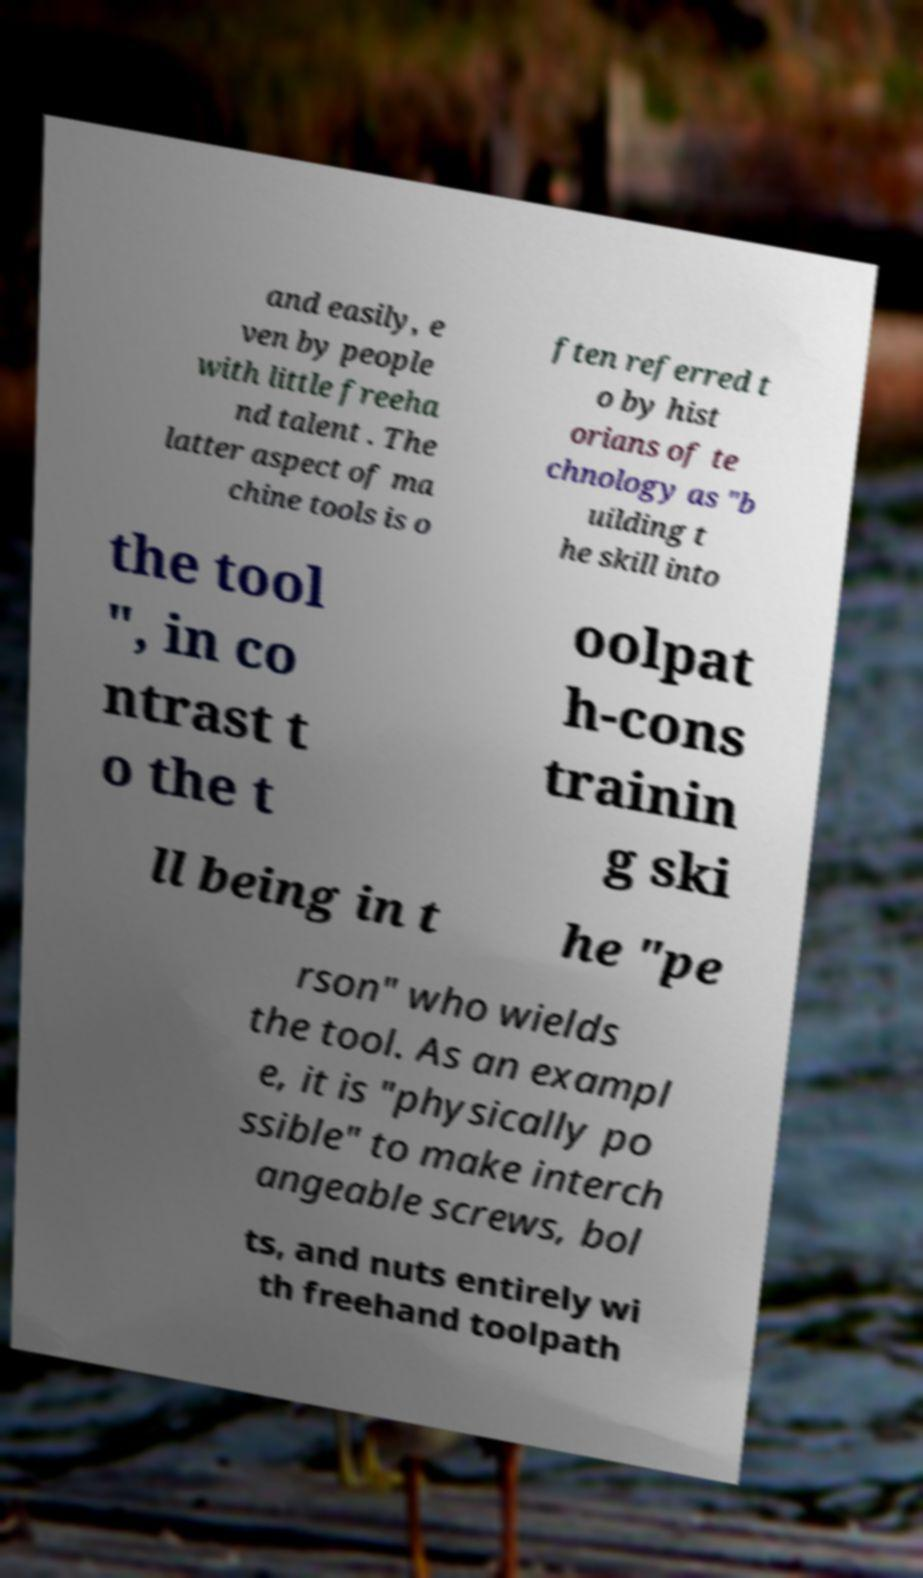Please read and relay the text visible in this image. What does it say? and easily, e ven by people with little freeha nd talent . The latter aspect of ma chine tools is o ften referred t o by hist orians of te chnology as "b uilding t he skill into the tool ", in co ntrast t o the t oolpat h-cons trainin g ski ll being in t he "pe rson" who wields the tool. As an exampl e, it is "physically po ssible" to make interch angeable screws, bol ts, and nuts entirely wi th freehand toolpath 